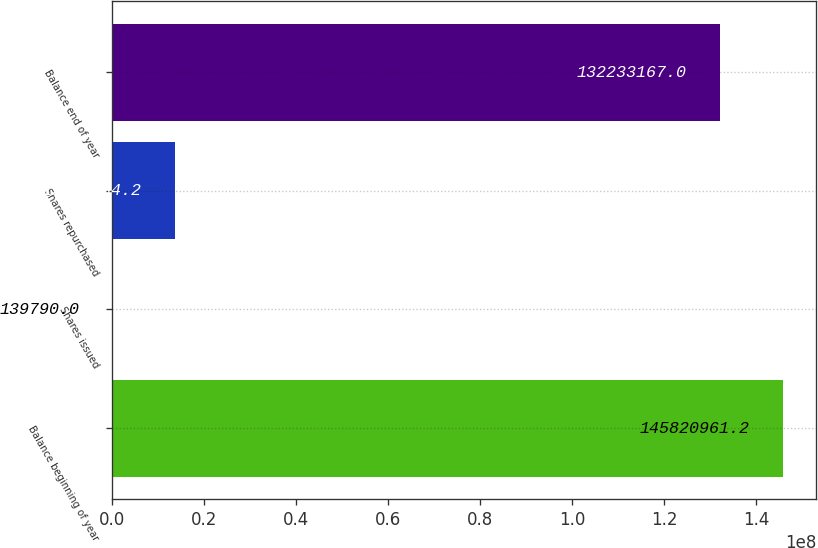Convert chart. <chart><loc_0><loc_0><loc_500><loc_500><bar_chart><fcel>Balance beginning of year<fcel>Shares issued<fcel>Shares repurchased<fcel>Balance end of year<nl><fcel>1.45821e+08<fcel>139790<fcel>1.37276e+07<fcel>1.32233e+08<nl></chart> 